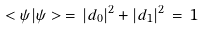Convert formula to latex. <formula><loc_0><loc_0><loc_500><loc_500>< \psi | \psi > \, = \, | d _ { 0 } | ^ { 2 } + | d _ { 1 } | ^ { 2 } \, = \, 1</formula> 